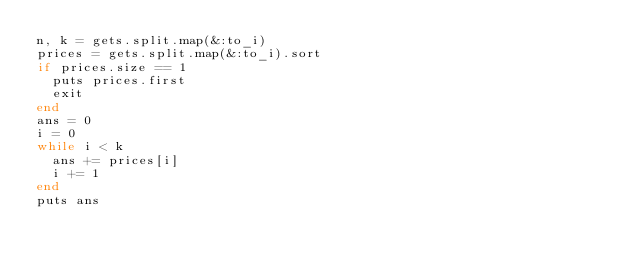Convert code to text. <code><loc_0><loc_0><loc_500><loc_500><_Ruby_>n, k = gets.split.map(&:to_i)
prices = gets.split.map(&:to_i).sort
if prices.size == 1
  puts prices.first
  exit
end
ans = 0
i = 0
while i < k
  ans += prices[i]
  i += 1
end
puts ans
</code> 